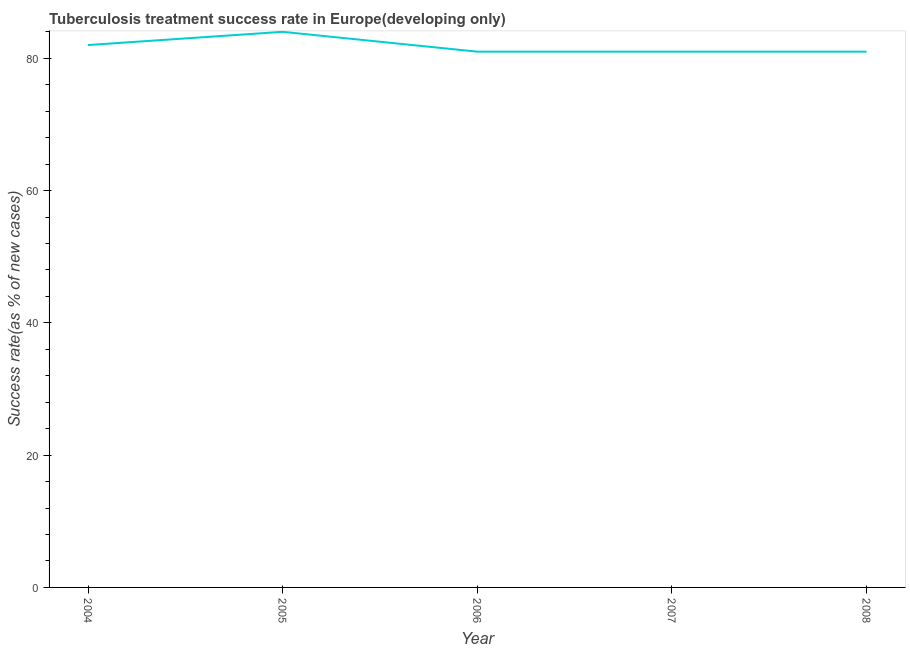What is the tuberculosis treatment success rate in 2004?
Give a very brief answer. 82. Across all years, what is the maximum tuberculosis treatment success rate?
Give a very brief answer. 84. Across all years, what is the minimum tuberculosis treatment success rate?
Offer a terse response. 81. In which year was the tuberculosis treatment success rate maximum?
Make the answer very short. 2005. What is the sum of the tuberculosis treatment success rate?
Ensure brevity in your answer.  409. What is the difference between the tuberculosis treatment success rate in 2005 and 2007?
Your response must be concise. 3. What is the average tuberculosis treatment success rate per year?
Provide a short and direct response. 81.8. In how many years, is the tuberculosis treatment success rate greater than 40 %?
Your answer should be very brief. 5. What is the difference between the highest and the second highest tuberculosis treatment success rate?
Provide a short and direct response. 2. Is the sum of the tuberculosis treatment success rate in 2004 and 2008 greater than the maximum tuberculosis treatment success rate across all years?
Keep it short and to the point. Yes. What is the difference between the highest and the lowest tuberculosis treatment success rate?
Your response must be concise. 3. In how many years, is the tuberculosis treatment success rate greater than the average tuberculosis treatment success rate taken over all years?
Your answer should be very brief. 2. Does the graph contain any zero values?
Offer a very short reply. No. Does the graph contain grids?
Offer a very short reply. No. What is the title of the graph?
Provide a short and direct response. Tuberculosis treatment success rate in Europe(developing only). What is the label or title of the X-axis?
Offer a terse response. Year. What is the label or title of the Y-axis?
Your answer should be compact. Success rate(as % of new cases). What is the Success rate(as % of new cases) of 2004?
Give a very brief answer. 82. What is the Success rate(as % of new cases) of 2005?
Make the answer very short. 84. What is the Success rate(as % of new cases) of 2008?
Your response must be concise. 81. What is the difference between the Success rate(as % of new cases) in 2004 and 2006?
Provide a short and direct response. 1. What is the difference between the Success rate(as % of new cases) in 2004 and 2008?
Your answer should be very brief. 1. What is the difference between the Success rate(as % of new cases) in 2005 and 2006?
Offer a very short reply. 3. What is the difference between the Success rate(as % of new cases) in 2006 and 2008?
Offer a very short reply. 0. What is the ratio of the Success rate(as % of new cases) in 2004 to that in 2005?
Offer a very short reply. 0.98. What is the ratio of the Success rate(as % of new cases) in 2004 to that in 2006?
Make the answer very short. 1.01. What is the ratio of the Success rate(as % of new cases) in 2005 to that in 2006?
Your answer should be compact. 1.04. What is the ratio of the Success rate(as % of new cases) in 2005 to that in 2007?
Give a very brief answer. 1.04. What is the ratio of the Success rate(as % of new cases) in 2005 to that in 2008?
Make the answer very short. 1.04. What is the ratio of the Success rate(as % of new cases) in 2006 to that in 2007?
Offer a terse response. 1. What is the ratio of the Success rate(as % of new cases) in 2006 to that in 2008?
Make the answer very short. 1. 